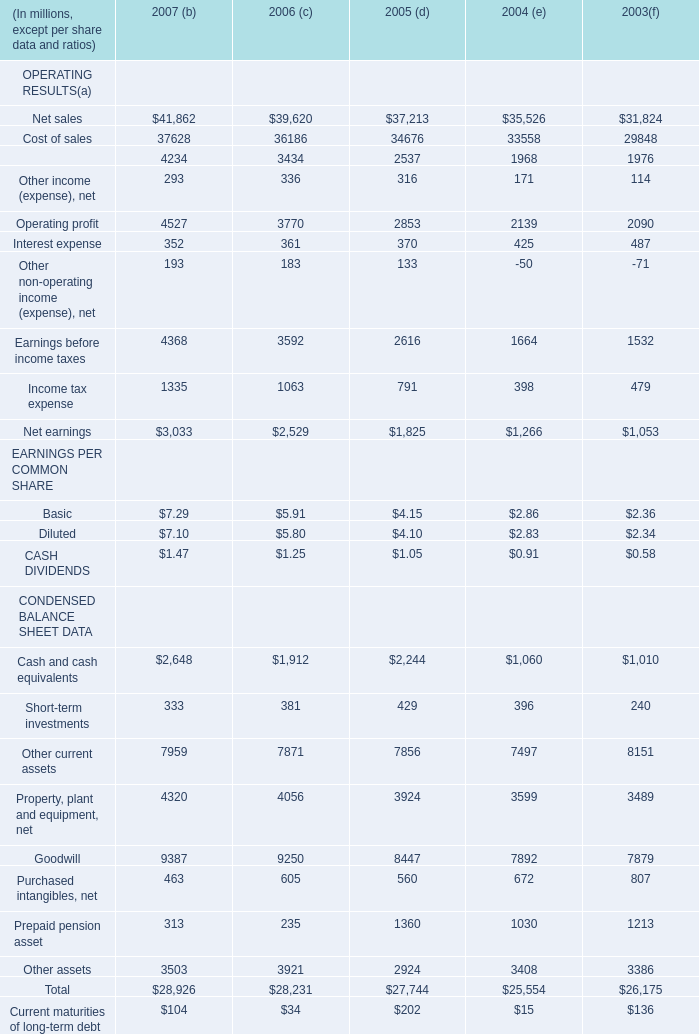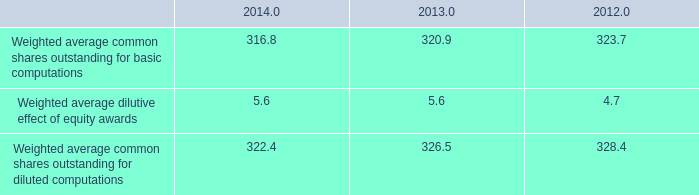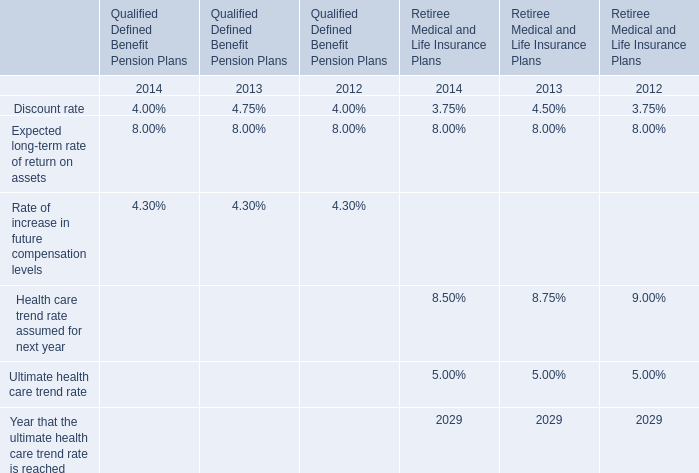in 2014 what was the ratio of the aggregate notional amount of outstanding interest rate swaps to the outstanding foreign currency hedges 
Computations: (1.3 / 804)
Answer: 0.00162. 